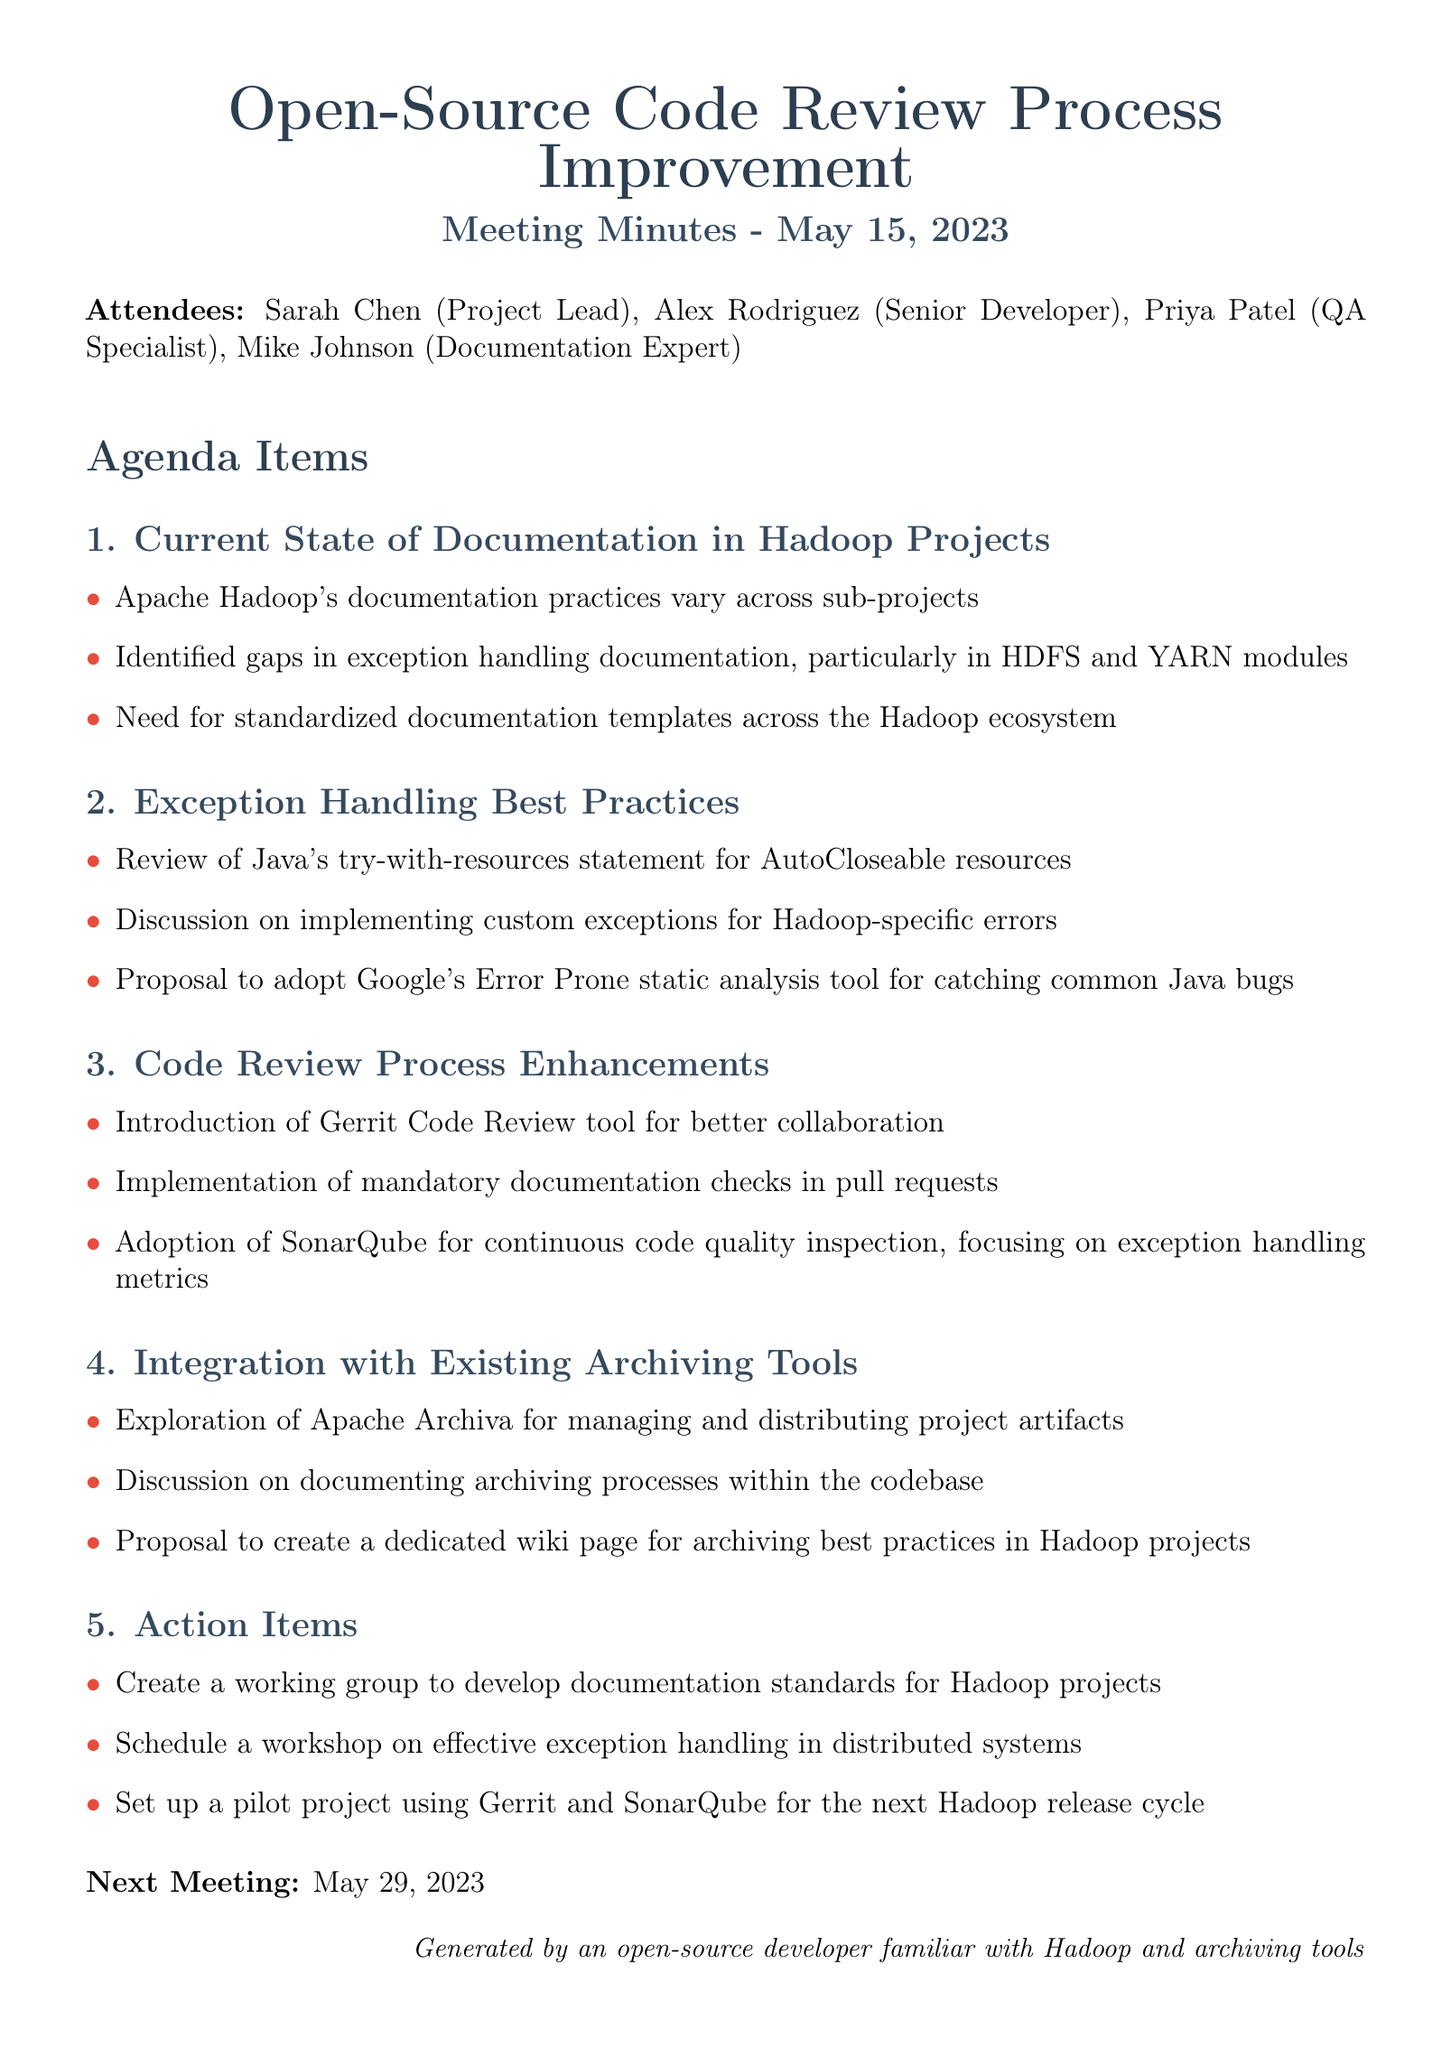What is the date of the meeting? The date of the meeting is explicitly stated in the document.
Answer: May 15, 2023 Who is the Project Lead? The attendees section lists the names and roles of the participants.
Answer: Sarah Chen What tool is proposed for code review collaboration? The document lists enhancements related to the code review process.
Answer: Gerrit Code Review What documentation gaps were identified in Hadoop projects? The points under the current state of documentation mention specific areas lacking documentation.
Answer: Exception handling What will the working group focus on? The action items specify the focus areas for the working group being formed.
Answer: Documentation standards What static analysis tool is proposed for common Java bugs? The exception handling best practices section suggests a specific tool for analysis.
Answer: Google's Error Prone What is one of the topics of discussion related to archiving tools? The archiving tools section includes discussions and proposals that are mentioned.
Answer: Documenting archiving processes When is the next meeting scheduled? The document specifies the date for the next meeting at the end.
Answer: May 29, 2023 